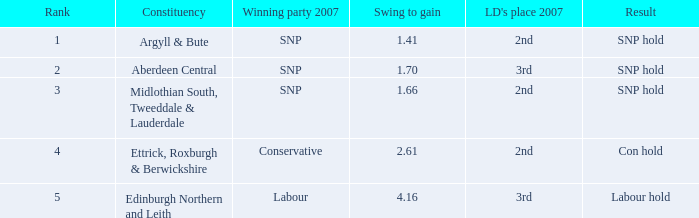How many times is the constituency edinburgh northern and leith? 1.0. 